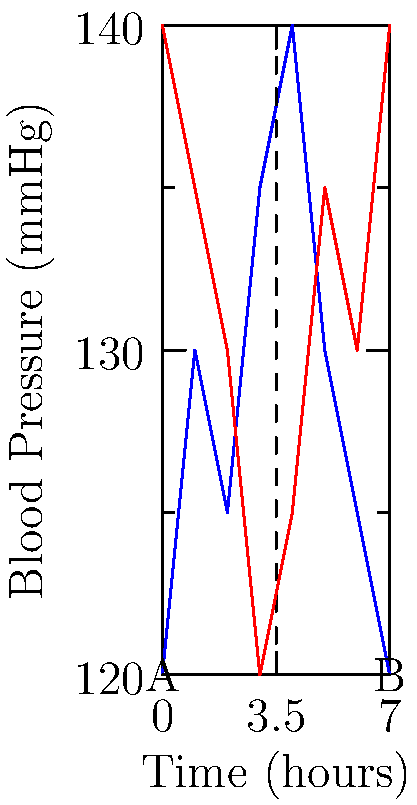A circular graph represents a patient's blood pressure data over 7 hours. The blue curve shows the original data, and the red curve is the result of a transformation. Describe the sequence of transformations applied to the blue curve to obtain the red curve. To transform the blue curve into the red curve, we need to follow these steps:

1) First, we need to identify the center of rotation. The dashed lines indicate that the center is at the point (3.5, 130), which is the midpoint of the graph both horizontally and vertically.

2) The red curve is an exact mirror image of the blue curve, rotated around this center point. This suggests a rotation of 180 degrees (or $\pi$ radians) around the point (3.5, 130).

3) In terms of transformations, this can be described as:
   a) Translation: Move the center of rotation to the origin (0, 0)
   b) Rotation: Rotate by 180 degrees around the origin
   c) Translation: Move back to the original center (3.5, 130)

4) Mathematically, this sequence of transformations can be represented as:
   $T(x,y) = R_{180°}(x-3.5, y-130) + (3.5, 130)$

   Where $R_{180°}$ represents a rotation by 180 degrees around the origin.

5) This transformation effectively "flips" the graph upside-down around the horizontal line y = 130, and left-to-right around the vertical line x = 3.5.

Therefore, the complete transformation is a rotation of 180 degrees around the point (3.5, 130).
Answer: 180° rotation around (3.5, 130) 